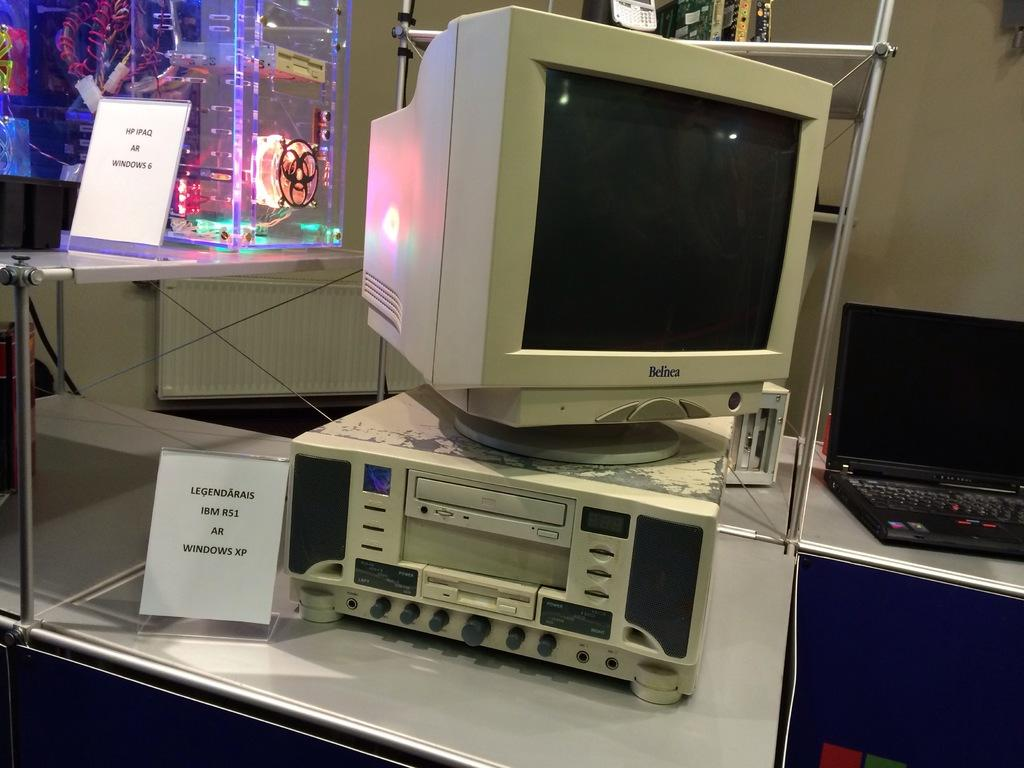Provide a one-sentence caption for the provided image. The computer on display is from the company Belnea.. 